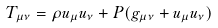<formula> <loc_0><loc_0><loc_500><loc_500>T _ { \mu \nu } = \rho u _ { \mu } u _ { \nu } + P ( g _ { \mu \nu } + u _ { \mu } u _ { \nu } )</formula> 